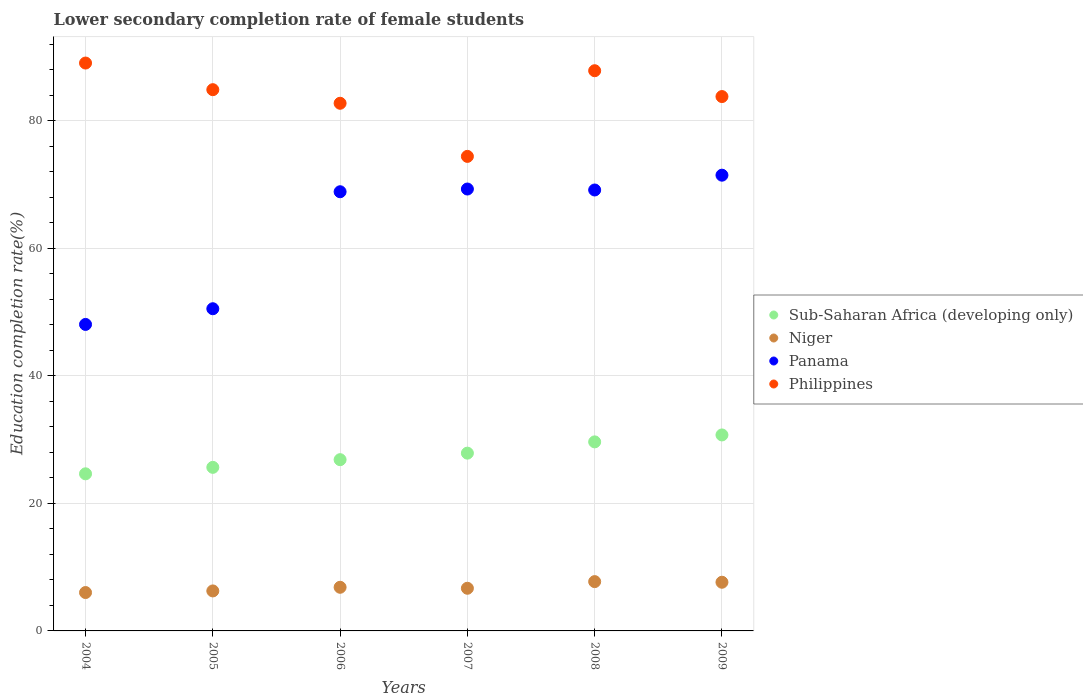How many different coloured dotlines are there?
Ensure brevity in your answer.  4. Is the number of dotlines equal to the number of legend labels?
Your answer should be compact. Yes. What is the lower secondary completion rate of female students in Niger in 2004?
Your response must be concise. 6.02. Across all years, what is the maximum lower secondary completion rate of female students in Sub-Saharan Africa (developing only)?
Provide a succinct answer. 30.73. Across all years, what is the minimum lower secondary completion rate of female students in Niger?
Provide a short and direct response. 6.02. In which year was the lower secondary completion rate of female students in Panama minimum?
Provide a short and direct response. 2004. What is the total lower secondary completion rate of female students in Philippines in the graph?
Your answer should be compact. 502.75. What is the difference between the lower secondary completion rate of female students in Sub-Saharan Africa (developing only) in 2004 and that in 2005?
Keep it short and to the point. -1.01. What is the difference between the lower secondary completion rate of female students in Philippines in 2004 and the lower secondary completion rate of female students in Panama in 2007?
Offer a very short reply. 19.76. What is the average lower secondary completion rate of female students in Sub-Saharan Africa (developing only) per year?
Provide a succinct answer. 27.57. In the year 2007, what is the difference between the lower secondary completion rate of female students in Panama and lower secondary completion rate of female students in Sub-Saharan Africa (developing only)?
Offer a terse response. 41.42. What is the ratio of the lower secondary completion rate of female students in Niger in 2006 to that in 2008?
Keep it short and to the point. 0.89. Is the lower secondary completion rate of female students in Panama in 2006 less than that in 2007?
Keep it short and to the point. Yes. What is the difference between the highest and the second highest lower secondary completion rate of female students in Sub-Saharan Africa (developing only)?
Offer a terse response. 1.09. What is the difference between the highest and the lowest lower secondary completion rate of female students in Niger?
Give a very brief answer. 1.71. Is the sum of the lower secondary completion rate of female students in Sub-Saharan Africa (developing only) in 2005 and 2007 greater than the maximum lower secondary completion rate of female students in Philippines across all years?
Make the answer very short. No. Is it the case that in every year, the sum of the lower secondary completion rate of female students in Panama and lower secondary completion rate of female students in Philippines  is greater than the sum of lower secondary completion rate of female students in Niger and lower secondary completion rate of female students in Sub-Saharan Africa (developing only)?
Your answer should be compact. Yes. Does the lower secondary completion rate of female students in Niger monotonically increase over the years?
Give a very brief answer. No. How many dotlines are there?
Your answer should be very brief. 4. What is the difference between two consecutive major ticks on the Y-axis?
Give a very brief answer. 20. Does the graph contain any zero values?
Give a very brief answer. No. Does the graph contain grids?
Provide a succinct answer. Yes. How many legend labels are there?
Make the answer very short. 4. How are the legend labels stacked?
Provide a short and direct response. Vertical. What is the title of the graph?
Your answer should be compact. Lower secondary completion rate of female students. What is the label or title of the X-axis?
Your answer should be very brief. Years. What is the label or title of the Y-axis?
Provide a succinct answer. Education completion rate(%). What is the Education completion rate(%) of Sub-Saharan Africa (developing only) in 2004?
Offer a very short reply. 24.64. What is the Education completion rate(%) in Niger in 2004?
Keep it short and to the point. 6.02. What is the Education completion rate(%) of Panama in 2004?
Offer a very short reply. 48.07. What is the Education completion rate(%) in Philippines in 2004?
Provide a short and direct response. 89.05. What is the Education completion rate(%) in Sub-Saharan Africa (developing only) in 2005?
Provide a short and direct response. 25.65. What is the Education completion rate(%) of Niger in 2005?
Provide a succinct answer. 6.27. What is the Education completion rate(%) in Panama in 2005?
Provide a succinct answer. 50.53. What is the Education completion rate(%) in Philippines in 2005?
Offer a terse response. 84.88. What is the Education completion rate(%) of Sub-Saharan Africa (developing only) in 2006?
Your response must be concise. 26.86. What is the Education completion rate(%) in Niger in 2006?
Offer a terse response. 6.84. What is the Education completion rate(%) of Panama in 2006?
Make the answer very short. 68.87. What is the Education completion rate(%) in Philippines in 2006?
Offer a terse response. 82.75. What is the Education completion rate(%) of Sub-Saharan Africa (developing only) in 2007?
Give a very brief answer. 27.88. What is the Education completion rate(%) of Niger in 2007?
Provide a succinct answer. 6.69. What is the Education completion rate(%) in Panama in 2007?
Ensure brevity in your answer.  69.3. What is the Education completion rate(%) in Philippines in 2007?
Provide a short and direct response. 74.42. What is the Education completion rate(%) of Sub-Saharan Africa (developing only) in 2008?
Your answer should be compact. 29.65. What is the Education completion rate(%) of Niger in 2008?
Provide a short and direct response. 7.73. What is the Education completion rate(%) of Panama in 2008?
Ensure brevity in your answer.  69.15. What is the Education completion rate(%) in Philippines in 2008?
Your answer should be compact. 87.85. What is the Education completion rate(%) of Sub-Saharan Africa (developing only) in 2009?
Make the answer very short. 30.73. What is the Education completion rate(%) of Niger in 2009?
Give a very brief answer. 7.63. What is the Education completion rate(%) of Panama in 2009?
Your answer should be very brief. 71.47. What is the Education completion rate(%) of Philippines in 2009?
Make the answer very short. 83.8. Across all years, what is the maximum Education completion rate(%) of Sub-Saharan Africa (developing only)?
Your response must be concise. 30.73. Across all years, what is the maximum Education completion rate(%) in Niger?
Your answer should be compact. 7.73. Across all years, what is the maximum Education completion rate(%) of Panama?
Keep it short and to the point. 71.47. Across all years, what is the maximum Education completion rate(%) in Philippines?
Give a very brief answer. 89.05. Across all years, what is the minimum Education completion rate(%) in Sub-Saharan Africa (developing only)?
Offer a terse response. 24.64. Across all years, what is the minimum Education completion rate(%) of Niger?
Provide a short and direct response. 6.02. Across all years, what is the minimum Education completion rate(%) of Panama?
Provide a short and direct response. 48.07. Across all years, what is the minimum Education completion rate(%) of Philippines?
Your answer should be very brief. 74.42. What is the total Education completion rate(%) of Sub-Saharan Africa (developing only) in the graph?
Ensure brevity in your answer.  165.41. What is the total Education completion rate(%) in Niger in the graph?
Make the answer very short. 41.19. What is the total Education completion rate(%) of Panama in the graph?
Give a very brief answer. 377.38. What is the total Education completion rate(%) in Philippines in the graph?
Your answer should be compact. 502.75. What is the difference between the Education completion rate(%) in Sub-Saharan Africa (developing only) in 2004 and that in 2005?
Ensure brevity in your answer.  -1.01. What is the difference between the Education completion rate(%) in Niger in 2004 and that in 2005?
Offer a terse response. -0.25. What is the difference between the Education completion rate(%) in Panama in 2004 and that in 2005?
Give a very brief answer. -2.46. What is the difference between the Education completion rate(%) of Philippines in 2004 and that in 2005?
Your response must be concise. 4.18. What is the difference between the Education completion rate(%) of Sub-Saharan Africa (developing only) in 2004 and that in 2006?
Your response must be concise. -2.22. What is the difference between the Education completion rate(%) of Niger in 2004 and that in 2006?
Your answer should be compact. -0.82. What is the difference between the Education completion rate(%) in Panama in 2004 and that in 2006?
Make the answer very short. -20.81. What is the difference between the Education completion rate(%) in Philippines in 2004 and that in 2006?
Your answer should be very brief. 6.31. What is the difference between the Education completion rate(%) of Sub-Saharan Africa (developing only) in 2004 and that in 2007?
Give a very brief answer. -3.24. What is the difference between the Education completion rate(%) of Niger in 2004 and that in 2007?
Your answer should be compact. -0.67. What is the difference between the Education completion rate(%) of Panama in 2004 and that in 2007?
Provide a short and direct response. -21.23. What is the difference between the Education completion rate(%) of Philippines in 2004 and that in 2007?
Your response must be concise. 14.64. What is the difference between the Education completion rate(%) in Sub-Saharan Africa (developing only) in 2004 and that in 2008?
Provide a short and direct response. -5.01. What is the difference between the Education completion rate(%) in Niger in 2004 and that in 2008?
Make the answer very short. -1.71. What is the difference between the Education completion rate(%) of Panama in 2004 and that in 2008?
Provide a succinct answer. -21.08. What is the difference between the Education completion rate(%) of Philippines in 2004 and that in 2008?
Your answer should be compact. 1.2. What is the difference between the Education completion rate(%) in Sub-Saharan Africa (developing only) in 2004 and that in 2009?
Provide a short and direct response. -6.1. What is the difference between the Education completion rate(%) of Niger in 2004 and that in 2009?
Ensure brevity in your answer.  -1.61. What is the difference between the Education completion rate(%) in Panama in 2004 and that in 2009?
Your response must be concise. -23.4. What is the difference between the Education completion rate(%) in Philippines in 2004 and that in 2009?
Ensure brevity in your answer.  5.26. What is the difference between the Education completion rate(%) in Sub-Saharan Africa (developing only) in 2005 and that in 2006?
Ensure brevity in your answer.  -1.21. What is the difference between the Education completion rate(%) of Niger in 2005 and that in 2006?
Your response must be concise. -0.57. What is the difference between the Education completion rate(%) in Panama in 2005 and that in 2006?
Give a very brief answer. -18.35. What is the difference between the Education completion rate(%) of Philippines in 2005 and that in 2006?
Keep it short and to the point. 2.13. What is the difference between the Education completion rate(%) in Sub-Saharan Africa (developing only) in 2005 and that in 2007?
Offer a very short reply. -2.23. What is the difference between the Education completion rate(%) of Niger in 2005 and that in 2007?
Provide a short and direct response. -0.42. What is the difference between the Education completion rate(%) of Panama in 2005 and that in 2007?
Keep it short and to the point. -18.77. What is the difference between the Education completion rate(%) in Philippines in 2005 and that in 2007?
Offer a very short reply. 10.46. What is the difference between the Education completion rate(%) of Sub-Saharan Africa (developing only) in 2005 and that in 2008?
Offer a very short reply. -4. What is the difference between the Education completion rate(%) in Niger in 2005 and that in 2008?
Make the answer very short. -1.46. What is the difference between the Education completion rate(%) in Panama in 2005 and that in 2008?
Give a very brief answer. -18.62. What is the difference between the Education completion rate(%) in Philippines in 2005 and that in 2008?
Provide a succinct answer. -2.97. What is the difference between the Education completion rate(%) of Sub-Saharan Africa (developing only) in 2005 and that in 2009?
Give a very brief answer. -5.08. What is the difference between the Education completion rate(%) in Niger in 2005 and that in 2009?
Offer a very short reply. -1.36. What is the difference between the Education completion rate(%) of Panama in 2005 and that in 2009?
Your response must be concise. -20.94. What is the difference between the Education completion rate(%) in Philippines in 2005 and that in 2009?
Your answer should be compact. 1.08. What is the difference between the Education completion rate(%) of Sub-Saharan Africa (developing only) in 2006 and that in 2007?
Ensure brevity in your answer.  -1.02. What is the difference between the Education completion rate(%) in Niger in 2006 and that in 2007?
Offer a terse response. 0.15. What is the difference between the Education completion rate(%) of Panama in 2006 and that in 2007?
Offer a very short reply. -0.43. What is the difference between the Education completion rate(%) of Philippines in 2006 and that in 2007?
Offer a very short reply. 8.33. What is the difference between the Education completion rate(%) of Sub-Saharan Africa (developing only) in 2006 and that in 2008?
Ensure brevity in your answer.  -2.79. What is the difference between the Education completion rate(%) of Niger in 2006 and that in 2008?
Give a very brief answer. -0.89. What is the difference between the Education completion rate(%) of Panama in 2006 and that in 2008?
Make the answer very short. -0.28. What is the difference between the Education completion rate(%) in Philippines in 2006 and that in 2008?
Provide a short and direct response. -5.1. What is the difference between the Education completion rate(%) in Sub-Saharan Africa (developing only) in 2006 and that in 2009?
Ensure brevity in your answer.  -3.88. What is the difference between the Education completion rate(%) in Niger in 2006 and that in 2009?
Ensure brevity in your answer.  -0.79. What is the difference between the Education completion rate(%) of Panama in 2006 and that in 2009?
Give a very brief answer. -2.6. What is the difference between the Education completion rate(%) in Philippines in 2006 and that in 2009?
Provide a succinct answer. -1.05. What is the difference between the Education completion rate(%) in Sub-Saharan Africa (developing only) in 2007 and that in 2008?
Provide a short and direct response. -1.77. What is the difference between the Education completion rate(%) in Niger in 2007 and that in 2008?
Ensure brevity in your answer.  -1.04. What is the difference between the Education completion rate(%) in Panama in 2007 and that in 2008?
Your answer should be very brief. 0.15. What is the difference between the Education completion rate(%) in Philippines in 2007 and that in 2008?
Keep it short and to the point. -13.43. What is the difference between the Education completion rate(%) in Sub-Saharan Africa (developing only) in 2007 and that in 2009?
Ensure brevity in your answer.  -2.85. What is the difference between the Education completion rate(%) of Niger in 2007 and that in 2009?
Keep it short and to the point. -0.94. What is the difference between the Education completion rate(%) of Panama in 2007 and that in 2009?
Keep it short and to the point. -2.17. What is the difference between the Education completion rate(%) of Philippines in 2007 and that in 2009?
Keep it short and to the point. -9.38. What is the difference between the Education completion rate(%) of Sub-Saharan Africa (developing only) in 2008 and that in 2009?
Your answer should be compact. -1.09. What is the difference between the Education completion rate(%) of Niger in 2008 and that in 2009?
Provide a succinct answer. 0.1. What is the difference between the Education completion rate(%) of Panama in 2008 and that in 2009?
Keep it short and to the point. -2.32. What is the difference between the Education completion rate(%) of Philippines in 2008 and that in 2009?
Ensure brevity in your answer.  4.05. What is the difference between the Education completion rate(%) of Sub-Saharan Africa (developing only) in 2004 and the Education completion rate(%) of Niger in 2005?
Your answer should be very brief. 18.37. What is the difference between the Education completion rate(%) of Sub-Saharan Africa (developing only) in 2004 and the Education completion rate(%) of Panama in 2005?
Offer a very short reply. -25.89. What is the difference between the Education completion rate(%) in Sub-Saharan Africa (developing only) in 2004 and the Education completion rate(%) in Philippines in 2005?
Offer a very short reply. -60.24. What is the difference between the Education completion rate(%) in Niger in 2004 and the Education completion rate(%) in Panama in 2005?
Offer a very short reply. -44.51. What is the difference between the Education completion rate(%) of Niger in 2004 and the Education completion rate(%) of Philippines in 2005?
Provide a short and direct response. -78.86. What is the difference between the Education completion rate(%) of Panama in 2004 and the Education completion rate(%) of Philippines in 2005?
Keep it short and to the point. -36.81. What is the difference between the Education completion rate(%) of Sub-Saharan Africa (developing only) in 2004 and the Education completion rate(%) of Niger in 2006?
Your answer should be compact. 17.79. What is the difference between the Education completion rate(%) in Sub-Saharan Africa (developing only) in 2004 and the Education completion rate(%) in Panama in 2006?
Provide a succinct answer. -44.24. What is the difference between the Education completion rate(%) in Sub-Saharan Africa (developing only) in 2004 and the Education completion rate(%) in Philippines in 2006?
Your answer should be very brief. -58.11. What is the difference between the Education completion rate(%) in Niger in 2004 and the Education completion rate(%) in Panama in 2006?
Ensure brevity in your answer.  -62.85. What is the difference between the Education completion rate(%) in Niger in 2004 and the Education completion rate(%) in Philippines in 2006?
Offer a very short reply. -76.73. What is the difference between the Education completion rate(%) of Panama in 2004 and the Education completion rate(%) of Philippines in 2006?
Offer a terse response. -34.68. What is the difference between the Education completion rate(%) in Sub-Saharan Africa (developing only) in 2004 and the Education completion rate(%) in Niger in 2007?
Ensure brevity in your answer.  17.95. What is the difference between the Education completion rate(%) of Sub-Saharan Africa (developing only) in 2004 and the Education completion rate(%) of Panama in 2007?
Offer a very short reply. -44.66. What is the difference between the Education completion rate(%) of Sub-Saharan Africa (developing only) in 2004 and the Education completion rate(%) of Philippines in 2007?
Ensure brevity in your answer.  -49.78. What is the difference between the Education completion rate(%) in Niger in 2004 and the Education completion rate(%) in Panama in 2007?
Your response must be concise. -63.28. What is the difference between the Education completion rate(%) of Niger in 2004 and the Education completion rate(%) of Philippines in 2007?
Offer a terse response. -68.4. What is the difference between the Education completion rate(%) of Panama in 2004 and the Education completion rate(%) of Philippines in 2007?
Make the answer very short. -26.35. What is the difference between the Education completion rate(%) in Sub-Saharan Africa (developing only) in 2004 and the Education completion rate(%) in Niger in 2008?
Give a very brief answer. 16.91. What is the difference between the Education completion rate(%) of Sub-Saharan Africa (developing only) in 2004 and the Education completion rate(%) of Panama in 2008?
Your response must be concise. -44.51. What is the difference between the Education completion rate(%) of Sub-Saharan Africa (developing only) in 2004 and the Education completion rate(%) of Philippines in 2008?
Make the answer very short. -63.21. What is the difference between the Education completion rate(%) of Niger in 2004 and the Education completion rate(%) of Panama in 2008?
Make the answer very short. -63.13. What is the difference between the Education completion rate(%) in Niger in 2004 and the Education completion rate(%) in Philippines in 2008?
Provide a short and direct response. -81.83. What is the difference between the Education completion rate(%) of Panama in 2004 and the Education completion rate(%) of Philippines in 2008?
Your response must be concise. -39.79. What is the difference between the Education completion rate(%) of Sub-Saharan Africa (developing only) in 2004 and the Education completion rate(%) of Niger in 2009?
Make the answer very short. 17. What is the difference between the Education completion rate(%) in Sub-Saharan Africa (developing only) in 2004 and the Education completion rate(%) in Panama in 2009?
Provide a succinct answer. -46.83. What is the difference between the Education completion rate(%) of Sub-Saharan Africa (developing only) in 2004 and the Education completion rate(%) of Philippines in 2009?
Provide a short and direct response. -59.16. What is the difference between the Education completion rate(%) of Niger in 2004 and the Education completion rate(%) of Panama in 2009?
Your response must be concise. -65.45. What is the difference between the Education completion rate(%) in Niger in 2004 and the Education completion rate(%) in Philippines in 2009?
Provide a succinct answer. -77.78. What is the difference between the Education completion rate(%) in Panama in 2004 and the Education completion rate(%) in Philippines in 2009?
Offer a very short reply. -35.73. What is the difference between the Education completion rate(%) of Sub-Saharan Africa (developing only) in 2005 and the Education completion rate(%) of Niger in 2006?
Ensure brevity in your answer.  18.81. What is the difference between the Education completion rate(%) of Sub-Saharan Africa (developing only) in 2005 and the Education completion rate(%) of Panama in 2006?
Make the answer very short. -43.22. What is the difference between the Education completion rate(%) in Sub-Saharan Africa (developing only) in 2005 and the Education completion rate(%) in Philippines in 2006?
Make the answer very short. -57.1. What is the difference between the Education completion rate(%) in Niger in 2005 and the Education completion rate(%) in Panama in 2006?
Offer a very short reply. -62.6. What is the difference between the Education completion rate(%) in Niger in 2005 and the Education completion rate(%) in Philippines in 2006?
Offer a very short reply. -76.48. What is the difference between the Education completion rate(%) of Panama in 2005 and the Education completion rate(%) of Philippines in 2006?
Your answer should be compact. -32.22. What is the difference between the Education completion rate(%) in Sub-Saharan Africa (developing only) in 2005 and the Education completion rate(%) in Niger in 2007?
Provide a succinct answer. 18.96. What is the difference between the Education completion rate(%) in Sub-Saharan Africa (developing only) in 2005 and the Education completion rate(%) in Panama in 2007?
Make the answer very short. -43.65. What is the difference between the Education completion rate(%) of Sub-Saharan Africa (developing only) in 2005 and the Education completion rate(%) of Philippines in 2007?
Offer a very short reply. -48.77. What is the difference between the Education completion rate(%) of Niger in 2005 and the Education completion rate(%) of Panama in 2007?
Give a very brief answer. -63.03. What is the difference between the Education completion rate(%) in Niger in 2005 and the Education completion rate(%) in Philippines in 2007?
Your answer should be compact. -68.15. What is the difference between the Education completion rate(%) in Panama in 2005 and the Education completion rate(%) in Philippines in 2007?
Your answer should be compact. -23.89. What is the difference between the Education completion rate(%) of Sub-Saharan Africa (developing only) in 2005 and the Education completion rate(%) of Niger in 2008?
Offer a terse response. 17.92. What is the difference between the Education completion rate(%) in Sub-Saharan Africa (developing only) in 2005 and the Education completion rate(%) in Panama in 2008?
Your answer should be very brief. -43.5. What is the difference between the Education completion rate(%) of Sub-Saharan Africa (developing only) in 2005 and the Education completion rate(%) of Philippines in 2008?
Provide a short and direct response. -62.2. What is the difference between the Education completion rate(%) in Niger in 2005 and the Education completion rate(%) in Panama in 2008?
Provide a short and direct response. -62.88. What is the difference between the Education completion rate(%) of Niger in 2005 and the Education completion rate(%) of Philippines in 2008?
Your answer should be compact. -81.58. What is the difference between the Education completion rate(%) of Panama in 2005 and the Education completion rate(%) of Philippines in 2008?
Your answer should be very brief. -37.33. What is the difference between the Education completion rate(%) in Sub-Saharan Africa (developing only) in 2005 and the Education completion rate(%) in Niger in 2009?
Your answer should be very brief. 18.02. What is the difference between the Education completion rate(%) in Sub-Saharan Africa (developing only) in 2005 and the Education completion rate(%) in Panama in 2009?
Offer a very short reply. -45.82. What is the difference between the Education completion rate(%) in Sub-Saharan Africa (developing only) in 2005 and the Education completion rate(%) in Philippines in 2009?
Keep it short and to the point. -58.15. What is the difference between the Education completion rate(%) of Niger in 2005 and the Education completion rate(%) of Panama in 2009?
Offer a terse response. -65.2. What is the difference between the Education completion rate(%) of Niger in 2005 and the Education completion rate(%) of Philippines in 2009?
Ensure brevity in your answer.  -77.53. What is the difference between the Education completion rate(%) in Panama in 2005 and the Education completion rate(%) in Philippines in 2009?
Provide a short and direct response. -33.27. What is the difference between the Education completion rate(%) in Sub-Saharan Africa (developing only) in 2006 and the Education completion rate(%) in Niger in 2007?
Your answer should be compact. 20.17. What is the difference between the Education completion rate(%) of Sub-Saharan Africa (developing only) in 2006 and the Education completion rate(%) of Panama in 2007?
Your answer should be compact. -42.44. What is the difference between the Education completion rate(%) in Sub-Saharan Africa (developing only) in 2006 and the Education completion rate(%) in Philippines in 2007?
Offer a very short reply. -47.56. What is the difference between the Education completion rate(%) in Niger in 2006 and the Education completion rate(%) in Panama in 2007?
Make the answer very short. -62.46. What is the difference between the Education completion rate(%) in Niger in 2006 and the Education completion rate(%) in Philippines in 2007?
Your answer should be compact. -67.57. What is the difference between the Education completion rate(%) of Panama in 2006 and the Education completion rate(%) of Philippines in 2007?
Your response must be concise. -5.54. What is the difference between the Education completion rate(%) of Sub-Saharan Africa (developing only) in 2006 and the Education completion rate(%) of Niger in 2008?
Give a very brief answer. 19.12. What is the difference between the Education completion rate(%) of Sub-Saharan Africa (developing only) in 2006 and the Education completion rate(%) of Panama in 2008?
Provide a short and direct response. -42.29. What is the difference between the Education completion rate(%) in Sub-Saharan Africa (developing only) in 2006 and the Education completion rate(%) in Philippines in 2008?
Provide a succinct answer. -61. What is the difference between the Education completion rate(%) of Niger in 2006 and the Education completion rate(%) of Panama in 2008?
Your answer should be compact. -62.3. What is the difference between the Education completion rate(%) in Niger in 2006 and the Education completion rate(%) in Philippines in 2008?
Give a very brief answer. -81.01. What is the difference between the Education completion rate(%) in Panama in 2006 and the Education completion rate(%) in Philippines in 2008?
Your answer should be very brief. -18.98. What is the difference between the Education completion rate(%) in Sub-Saharan Africa (developing only) in 2006 and the Education completion rate(%) in Niger in 2009?
Your answer should be very brief. 19.22. What is the difference between the Education completion rate(%) in Sub-Saharan Africa (developing only) in 2006 and the Education completion rate(%) in Panama in 2009?
Make the answer very short. -44.61. What is the difference between the Education completion rate(%) in Sub-Saharan Africa (developing only) in 2006 and the Education completion rate(%) in Philippines in 2009?
Your answer should be very brief. -56.94. What is the difference between the Education completion rate(%) in Niger in 2006 and the Education completion rate(%) in Panama in 2009?
Keep it short and to the point. -64.63. What is the difference between the Education completion rate(%) of Niger in 2006 and the Education completion rate(%) of Philippines in 2009?
Your answer should be compact. -76.96. What is the difference between the Education completion rate(%) in Panama in 2006 and the Education completion rate(%) in Philippines in 2009?
Ensure brevity in your answer.  -14.93. What is the difference between the Education completion rate(%) in Sub-Saharan Africa (developing only) in 2007 and the Education completion rate(%) in Niger in 2008?
Offer a very short reply. 20.15. What is the difference between the Education completion rate(%) of Sub-Saharan Africa (developing only) in 2007 and the Education completion rate(%) of Panama in 2008?
Provide a short and direct response. -41.27. What is the difference between the Education completion rate(%) of Sub-Saharan Africa (developing only) in 2007 and the Education completion rate(%) of Philippines in 2008?
Ensure brevity in your answer.  -59.97. What is the difference between the Education completion rate(%) of Niger in 2007 and the Education completion rate(%) of Panama in 2008?
Give a very brief answer. -62.46. What is the difference between the Education completion rate(%) in Niger in 2007 and the Education completion rate(%) in Philippines in 2008?
Give a very brief answer. -81.16. What is the difference between the Education completion rate(%) in Panama in 2007 and the Education completion rate(%) in Philippines in 2008?
Make the answer very short. -18.55. What is the difference between the Education completion rate(%) in Sub-Saharan Africa (developing only) in 2007 and the Education completion rate(%) in Niger in 2009?
Your response must be concise. 20.25. What is the difference between the Education completion rate(%) in Sub-Saharan Africa (developing only) in 2007 and the Education completion rate(%) in Panama in 2009?
Provide a succinct answer. -43.59. What is the difference between the Education completion rate(%) in Sub-Saharan Africa (developing only) in 2007 and the Education completion rate(%) in Philippines in 2009?
Make the answer very short. -55.92. What is the difference between the Education completion rate(%) of Niger in 2007 and the Education completion rate(%) of Panama in 2009?
Ensure brevity in your answer.  -64.78. What is the difference between the Education completion rate(%) of Niger in 2007 and the Education completion rate(%) of Philippines in 2009?
Keep it short and to the point. -77.11. What is the difference between the Education completion rate(%) of Panama in 2007 and the Education completion rate(%) of Philippines in 2009?
Provide a short and direct response. -14.5. What is the difference between the Education completion rate(%) in Sub-Saharan Africa (developing only) in 2008 and the Education completion rate(%) in Niger in 2009?
Your answer should be compact. 22.01. What is the difference between the Education completion rate(%) in Sub-Saharan Africa (developing only) in 2008 and the Education completion rate(%) in Panama in 2009?
Keep it short and to the point. -41.82. What is the difference between the Education completion rate(%) of Sub-Saharan Africa (developing only) in 2008 and the Education completion rate(%) of Philippines in 2009?
Make the answer very short. -54.15. What is the difference between the Education completion rate(%) of Niger in 2008 and the Education completion rate(%) of Panama in 2009?
Offer a terse response. -63.74. What is the difference between the Education completion rate(%) in Niger in 2008 and the Education completion rate(%) in Philippines in 2009?
Your answer should be very brief. -76.07. What is the difference between the Education completion rate(%) of Panama in 2008 and the Education completion rate(%) of Philippines in 2009?
Keep it short and to the point. -14.65. What is the average Education completion rate(%) of Sub-Saharan Africa (developing only) per year?
Provide a succinct answer. 27.57. What is the average Education completion rate(%) in Niger per year?
Your answer should be compact. 6.86. What is the average Education completion rate(%) in Panama per year?
Give a very brief answer. 62.9. What is the average Education completion rate(%) of Philippines per year?
Keep it short and to the point. 83.79. In the year 2004, what is the difference between the Education completion rate(%) in Sub-Saharan Africa (developing only) and Education completion rate(%) in Niger?
Provide a succinct answer. 18.62. In the year 2004, what is the difference between the Education completion rate(%) of Sub-Saharan Africa (developing only) and Education completion rate(%) of Panama?
Make the answer very short. -23.43. In the year 2004, what is the difference between the Education completion rate(%) in Sub-Saharan Africa (developing only) and Education completion rate(%) in Philippines?
Provide a short and direct response. -64.42. In the year 2004, what is the difference between the Education completion rate(%) in Niger and Education completion rate(%) in Panama?
Make the answer very short. -42.05. In the year 2004, what is the difference between the Education completion rate(%) in Niger and Education completion rate(%) in Philippines?
Make the answer very short. -83.04. In the year 2004, what is the difference between the Education completion rate(%) in Panama and Education completion rate(%) in Philippines?
Your answer should be very brief. -40.99. In the year 2005, what is the difference between the Education completion rate(%) in Sub-Saharan Africa (developing only) and Education completion rate(%) in Niger?
Give a very brief answer. 19.38. In the year 2005, what is the difference between the Education completion rate(%) of Sub-Saharan Africa (developing only) and Education completion rate(%) of Panama?
Ensure brevity in your answer.  -24.88. In the year 2005, what is the difference between the Education completion rate(%) of Sub-Saharan Africa (developing only) and Education completion rate(%) of Philippines?
Make the answer very short. -59.23. In the year 2005, what is the difference between the Education completion rate(%) of Niger and Education completion rate(%) of Panama?
Your answer should be very brief. -44.25. In the year 2005, what is the difference between the Education completion rate(%) of Niger and Education completion rate(%) of Philippines?
Offer a terse response. -78.61. In the year 2005, what is the difference between the Education completion rate(%) in Panama and Education completion rate(%) in Philippines?
Offer a terse response. -34.35. In the year 2006, what is the difference between the Education completion rate(%) of Sub-Saharan Africa (developing only) and Education completion rate(%) of Niger?
Keep it short and to the point. 20.01. In the year 2006, what is the difference between the Education completion rate(%) of Sub-Saharan Africa (developing only) and Education completion rate(%) of Panama?
Give a very brief answer. -42.02. In the year 2006, what is the difference between the Education completion rate(%) in Sub-Saharan Africa (developing only) and Education completion rate(%) in Philippines?
Provide a short and direct response. -55.89. In the year 2006, what is the difference between the Education completion rate(%) in Niger and Education completion rate(%) in Panama?
Offer a terse response. -62.03. In the year 2006, what is the difference between the Education completion rate(%) of Niger and Education completion rate(%) of Philippines?
Your response must be concise. -75.9. In the year 2006, what is the difference between the Education completion rate(%) of Panama and Education completion rate(%) of Philippines?
Offer a terse response. -13.87. In the year 2007, what is the difference between the Education completion rate(%) in Sub-Saharan Africa (developing only) and Education completion rate(%) in Niger?
Your answer should be compact. 21.19. In the year 2007, what is the difference between the Education completion rate(%) in Sub-Saharan Africa (developing only) and Education completion rate(%) in Panama?
Offer a terse response. -41.42. In the year 2007, what is the difference between the Education completion rate(%) of Sub-Saharan Africa (developing only) and Education completion rate(%) of Philippines?
Ensure brevity in your answer.  -46.54. In the year 2007, what is the difference between the Education completion rate(%) in Niger and Education completion rate(%) in Panama?
Your answer should be very brief. -62.61. In the year 2007, what is the difference between the Education completion rate(%) in Niger and Education completion rate(%) in Philippines?
Provide a succinct answer. -67.73. In the year 2007, what is the difference between the Education completion rate(%) in Panama and Education completion rate(%) in Philippines?
Give a very brief answer. -5.12. In the year 2008, what is the difference between the Education completion rate(%) of Sub-Saharan Africa (developing only) and Education completion rate(%) of Niger?
Make the answer very short. 21.91. In the year 2008, what is the difference between the Education completion rate(%) of Sub-Saharan Africa (developing only) and Education completion rate(%) of Panama?
Your response must be concise. -39.5. In the year 2008, what is the difference between the Education completion rate(%) of Sub-Saharan Africa (developing only) and Education completion rate(%) of Philippines?
Make the answer very short. -58.21. In the year 2008, what is the difference between the Education completion rate(%) of Niger and Education completion rate(%) of Panama?
Your answer should be compact. -61.42. In the year 2008, what is the difference between the Education completion rate(%) of Niger and Education completion rate(%) of Philippines?
Keep it short and to the point. -80.12. In the year 2008, what is the difference between the Education completion rate(%) in Panama and Education completion rate(%) in Philippines?
Provide a short and direct response. -18.7. In the year 2009, what is the difference between the Education completion rate(%) in Sub-Saharan Africa (developing only) and Education completion rate(%) in Niger?
Provide a succinct answer. 23.1. In the year 2009, what is the difference between the Education completion rate(%) in Sub-Saharan Africa (developing only) and Education completion rate(%) in Panama?
Make the answer very short. -40.74. In the year 2009, what is the difference between the Education completion rate(%) of Sub-Saharan Africa (developing only) and Education completion rate(%) of Philippines?
Keep it short and to the point. -53.07. In the year 2009, what is the difference between the Education completion rate(%) of Niger and Education completion rate(%) of Panama?
Offer a terse response. -63.84. In the year 2009, what is the difference between the Education completion rate(%) of Niger and Education completion rate(%) of Philippines?
Your answer should be compact. -76.17. In the year 2009, what is the difference between the Education completion rate(%) of Panama and Education completion rate(%) of Philippines?
Offer a terse response. -12.33. What is the ratio of the Education completion rate(%) in Sub-Saharan Africa (developing only) in 2004 to that in 2005?
Ensure brevity in your answer.  0.96. What is the ratio of the Education completion rate(%) in Niger in 2004 to that in 2005?
Your answer should be compact. 0.96. What is the ratio of the Education completion rate(%) in Panama in 2004 to that in 2005?
Your response must be concise. 0.95. What is the ratio of the Education completion rate(%) in Philippines in 2004 to that in 2005?
Your answer should be very brief. 1.05. What is the ratio of the Education completion rate(%) in Sub-Saharan Africa (developing only) in 2004 to that in 2006?
Give a very brief answer. 0.92. What is the ratio of the Education completion rate(%) in Niger in 2004 to that in 2006?
Offer a very short reply. 0.88. What is the ratio of the Education completion rate(%) of Panama in 2004 to that in 2006?
Your answer should be very brief. 0.7. What is the ratio of the Education completion rate(%) of Philippines in 2004 to that in 2006?
Keep it short and to the point. 1.08. What is the ratio of the Education completion rate(%) of Sub-Saharan Africa (developing only) in 2004 to that in 2007?
Your response must be concise. 0.88. What is the ratio of the Education completion rate(%) of Niger in 2004 to that in 2007?
Provide a succinct answer. 0.9. What is the ratio of the Education completion rate(%) of Panama in 2004 to that in 2007?
Give a very brief answer. 0.69. What is the ratio of the Education completion rate(%) in Philippines in 2004 to that in 2007?
Offer a very short reply. 1.2. What is the ratio of the Education completion rate(%) of Sub-Saharan Africa (developing only) in 2004 to that in 2008?
Your answer should be very brief. 0.83. What is the ratio of the Education completion rate(%) in Niger in 2004 to that in 2008?
Ensure brevity in your answer.  0.78. What is the ratio of the Education completion rate(%) in Panama in 2004 to that in 2008?
Give a very brief answer. 0.7. What is the ratio of the Education completion rate(%) in Philippines in 2004 to that in 2008?
Keep it short and to the point. 1.01. What is the ratio of the Education completion rate(%) in Sub-Saharan Africa (developing only) in 2004 to that in 2009?
Your answer should be very brief. 0.8. What is the ratio of the Education completion rate(%) in Niger in 2004 to that in 2009?
Provide a short and direct response. 0.79. What is the ratio of the Education completion rate(%) of Panama in 2004 to that in 2009?
Offer a very short reply. 0.67. What is the ratio of the Education completion rate(%) in Philippines in 2004 to that in 2009?
Give a very brief answer. 1.06. What is the ratio of the Education completion rate(%) of Sub-Saharan Africa (developing only) in 2005 to that in 2006?
Offer a terse response. 0.96. What is the ratio of the Education completion rate(%) of Niger in 2005 to that in 2006?
Your response must be concise. 0.92. What is the ratio of the Education completion rate(%) of Panama in 2005 to that in 2006?
Give a very brief answer. 0.73. What is the ratio of the Education completion rate(%) in Philippines in 2005 to that in 2006?
Your answer should be very brief. 1.03. What is the ratio of the Education completion rate(%) of Sub-Saharan Africa (developing only) in 2005 to that in 2007?
Your response must be concise. 0.92. What is the ratio of the Education completion rate(%) of Panama in 2005 to that in 2007?
Your response must be concise. 0.73. What is the ratio of the Education completion rate(%) of Philippines in 2005 to that in 2007?
Give a very brief answer. 1.14. What is the ratio of the Education completion rate(%) in Sub-Saharan Africa (developing only) in 2005 to that in 2008?
Your answer should be compact. 0.87. What is the ratio of the Education completion rate(%) of Niger in 2005 to that in 2008?
Your answer should be very brief. 0.81. What is the ratio of the Education completion rate(%) of Panama in 2005 to that in 2008?
Make the answer very short. 0.73. What is the ratio of the Education completion rate(%) of Philippines in 2005 to that in 2008?
Your answer should be compact. 0.97. What is the ratio of the Education completion rate(%) of Sub-Saharan Africa (developing only) in 2005 to that in 2009?
Keep it short and to the point. 0.83. What is the ratio of the Education completion rate(%) of Niger in 2005 to that in 2009?
Your answer should be compact. 0.82. What is the ratio of the Education completion rate(%) in Panama in 2005 to that in 2009?
Ensure brevity in your answer.  0.71. What is the ratio of the Education completion rate(%) in Philippines in 2005 to that in 2009?
Offer a terse response. 1.01. What is the ratio of the Education completion rate(%) in Sub-Saharan Africa (developing only) in 2006 to that in 2007?
Your answer should be compact. 0.96. What is the ratio of the Education completion rate(%) of Niger in 2006 to that in 2007?
Provide a short and direct response. 1.02. What is the ratio of the Education completion rate(%) in Philippines in 2006 to that in 2007?
Provide a succinct answer. 1.11. What is the ratio of the Education completion rate(%) of Sub-Saharan Africa (developing only) in 2006 to that in 2008?
Give a very brief answer. 0.91. What is the ratio of the Education completion rate(%) in Niger in 2006 to that in 2008?
Keep it short and to the point. 0.89. What is the ratio of the Education completion rate(%) of Panama in 2006 to that in 2008?
Your response must be concise. 1. What is the ratio of the Education completion rate(%) of Philippines in 2006 to that in 2008?
Provide a short and direct response. 0.94. What is the ratio of the Education completion rate(%) in Sub-Saharan Africa (developing only) in 2006 to that in 2009?
Your answer should be very brief. 0.87. What is the ratio of the Education completion rate(%) in Niger in 2006 to that in 2009?
Offer a terse response. 0.9. What is the ratio of the Education completion rate(%) in Panama in 2006 to that in 2009?
Make the answer very short. 0.96. What is the ratio of the Education completion rate(%) in Philippines in 2006 to that in 2009?
Your answer should be compact. 0.99. What is the ratio of the Education completion rate(%) in Sub-Saharan Africa (developing only) in 2007 to that in 2008?
Make the answer very short. 0.94. What is the ratio of the Education completion rate(%) of Niger in 2007 to that in 2008?
Provide a short and direct response. 0.87. What is the ratio of the Education completion rate(%) of Philippines in 2007 to that in 2008?
Provide a succinct answer. 0.85. What is the ratio of the Education completion rate(%) of Sub-Saharan Africa (developing only) in 2007 to that in 2009?
Your response must be concise. 0.91. What is the ratio of the Education completion rate(%) of Niger in 2007 to that in 2009?
Ensure brevity in your answer.  0.88. What is the ratio of the Education completion rate(%) in Panama in 2007 to that in 2009?
Provide a succinct answer. 0.97. What is the ratio of the Education completion rate(%) in Philippines in 2007 to that in 2009?
Give a very brief answer. 0.89. What is the ratio of the Education completion rate(%) of Sub-Saharan Africa (developing only) in 2008 to that in 2009?
Your answer should be very brief. 0.96. What is the ratio of the Education completion rate(%) in Niger in 2008 to that in 2009?
Give a very brief answer. 1.01. What is the ratio of the Education completion rate(%) of Panama in 2008 to that in 2009?
Provide a short and direct response. 0.97. What is the ratio of the Education completion rate(%) of Philippines in 2008 to that in 2009?
Keep it short and to the point. 1.05. What is the difference between the highest and the second highest Education completion rate(%) of Sub-Saharan Africa (developing only)?
Provide a short and direct response. 1.09. What is the difference between the highest and the second highest Education completion rate(%) of Niger?
Provide a succinct answer. 0.1. What is the difference between the highest and the second highest Education completion rate(%) of Panama?
Give a very brief answer. 2.17. What is the difference between the highest and the second highest Education completion rate(%) of Philippines?
Offer a terse response. 1.2. What is the difference between the highest and the lowest Education completion rate(%) of Sub-Saharan Africa (developing only)?
Your answer should be very brief. 6.1. What is the difference between the highest and the lowest Education completion rate(%) of Niger?
Your answer should be compact. 1.71. What is the difference between the highest and the lowest Education completion rate(%) in Panama?
Your response must be concise. 23.4. What is the difference between the highest and the lowest Education completion rate(%) in Philippines?
Offer a terse response. 14.64. 